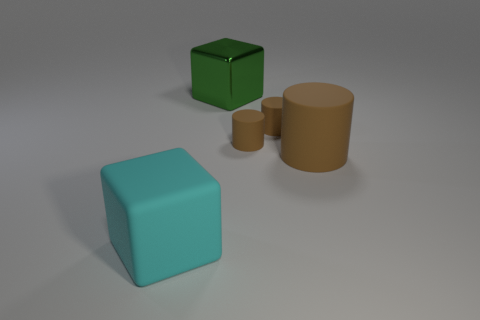Is the size of the matte cube the same as the green block?
Offer a terse response. Yes. There is a large object that is the same material as the large cylinder; what is its color?
Make the answer very short. Cyan. Are there the same number of big brown rubber cylinders to the left of the large cyan matte block and large matte blocks right of the large brown rubber thing?
Offer a terse response. Yes. What is the shape of the large rubber thing on the right side of the large block that is on the left side of the green object?
Offer a terse response. Cylinder. There is another thing that is the same shape as the green thing; what material is it?
Offer a terse response. Rubber. What color is the rubber cylinder that is the same size as the green shiny cube?
Provide a short and direct response. Brown. Is the number of tiny brown objects that are behind the green metallic thing the same as the number of big cyan spheres?
Your answer should be compact. Yes. There is a big cube that is behind the large rubber object that is left of the big green thing; what is its color?
Keep it short and to the point. Green. There is a block on the right side of the cube in front of the green block; what size is it?
Keep it short and to the point. Large. How many other objects are the same size as the cyan cube?
Offer a very short reply. 2. 